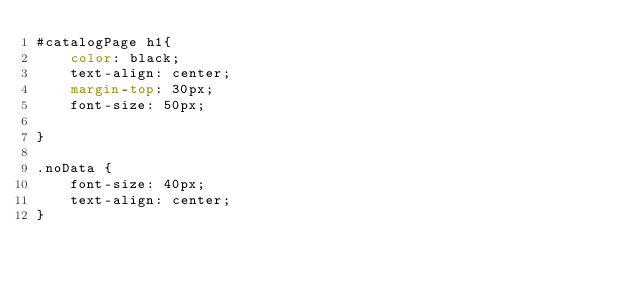<code> <loc_0><loc_0><loc_500><loc_500><_CSS_>#catalogPage h1{
    color: black;
    text-align: center;
    margin-top: 30px;
    font-size: 50px;
    
}

.noData {
    font-size: 40px;
    text-align: center;
}
</code> 